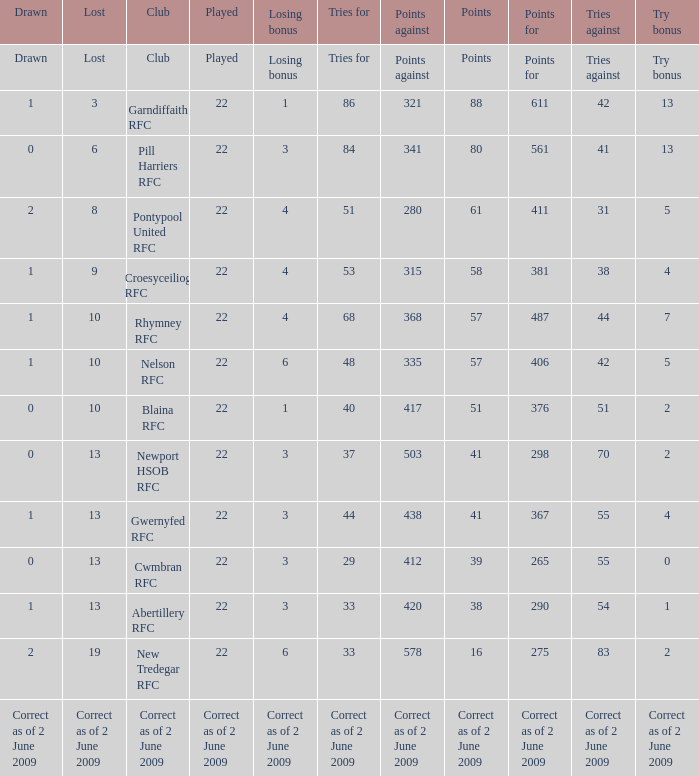How many tries against did the club with 1 drawn and 41 points have? 55.0. 